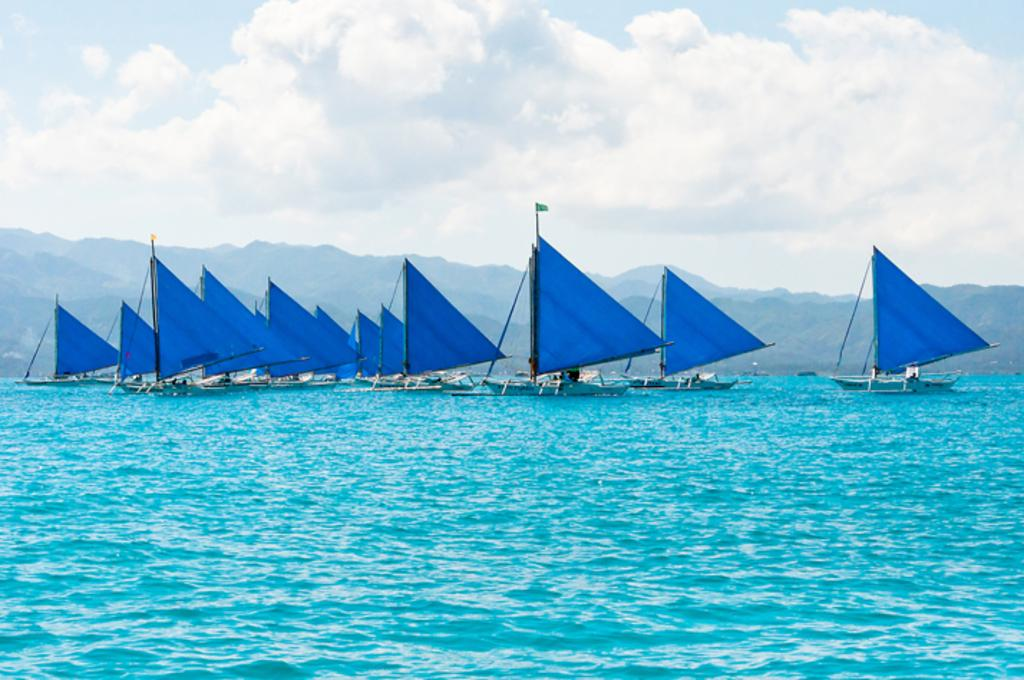What is in the front of the image? There is water in the front of the image. What is happening on the water? There are boats sailing on the water. What can be seen in the background of the image? There are mountains in the background of the image. How would you describe the sky in the image? The sky is cloudy. Where is the jar located in the image? There is no jar present in the image. What type of club can be seen in the image? There is no club present in the image. 